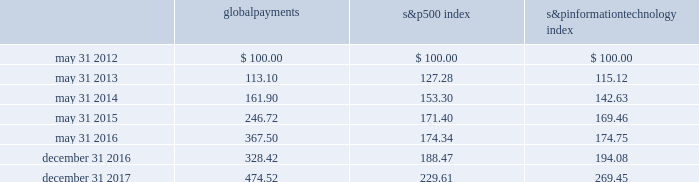Stock performance graph the following graph compares our cumulative shareholder returns with the standard & poor 2019s information technology index and the standard & poor 2019s 500 index for the year ended december 31 , 2017 , the 2016 fiscal transition period , and the years ended may 31 , 2016 , 2015 , 2014 and 2013 .
The line graph assumes the investment of $ 100 in our common stock , the standard & poor 2019s 500 index and the standard & poor 2019s information technology index on may 31 , 2012 and assumes reinvestment of all dividends .
5/12 5/165/155/145/13 global payments inc .
S&p 500 s&p information technology 12/16 12/17 comparison of 5 year cumulative total return* among global payments inc. , the s&p 500 index and the s&p information technology index * $ 100 invested on may 31 , 2012 in stock or index , including reinvestment of dividends .
Copyright a9 2018 standard & poor 2019s , a division of s&p global .
All rights reserved .
Global payments 500 index information technology .
30 2013 global payments inc .
| 2017 form 10-k annual report .
What is the total return if 1000000 is invested in s&p500 in may 31 , 2012 and liquidated in may 31 , 2015? 
Computations: ((1000000 / 100) * (171.40 - 100))
Answer: 714000.0. 